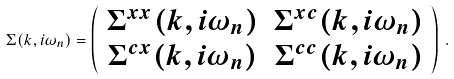Convert formula to latex. <formula><loc_0><loc_0><loc_500><loc_500>\Sigma ( { k } , i \omega _ { n } ) = \left ( \begin{array} { c c } \Sigma ^ { x x } ( { k } , i \omega _ { n } ) & \Sigma ^ { x c } ( { k } , i \omega _ { n } ) \\ \Sigma ^ { c x } ( { k } , i \omega _ { n } ) & \Sigma ^ { c c } ( { k } , i \omega _ { n } ) \end{array} \right ) \, .</formula> 